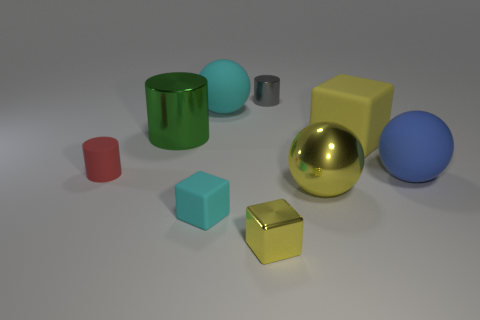The image appears to be illuminated by a light source. Where do you think the light source is located based on the shadows and highlights? The placement of shadows and highlights in the scene suggests that the light source is positioned off the top left of the frame. This is evidenced by the shadows cast towards the bottom right of the objects, and the highlights visible on the upper left edges of the objects, which are most prominent on the reflective surfaces such as the shiny yellow sphere and the green cylinder. 